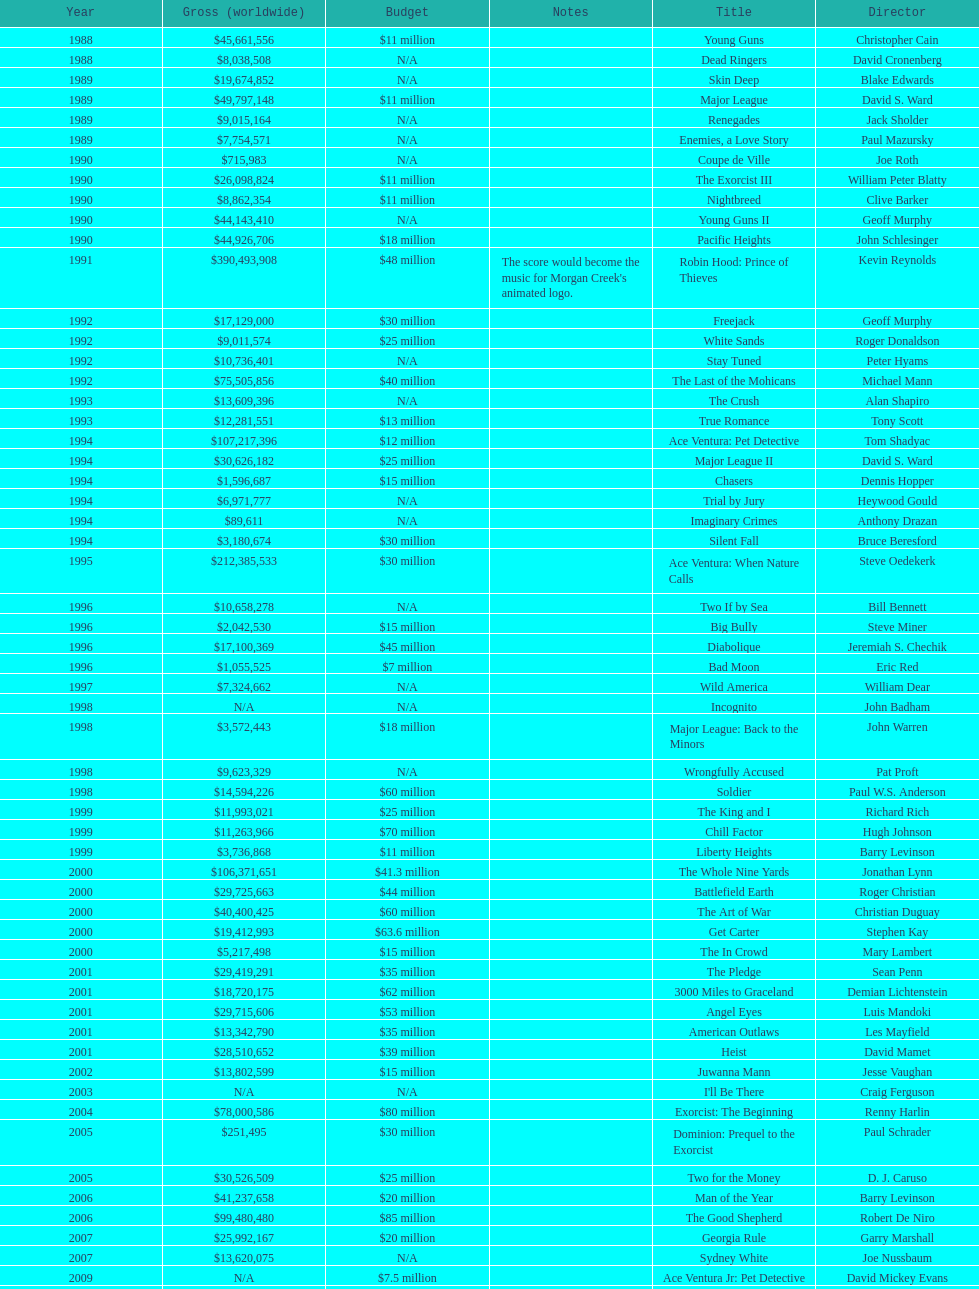Which film had a higher budget, ace ventura: when nature calls, or major league: back to the minors? Ace Ventura: When Nature Calls. 